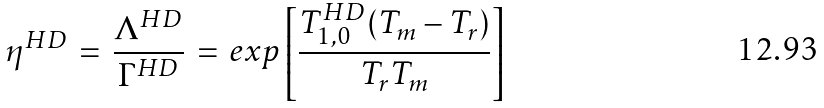<formula> <loc_0><loc_0><loc_500><loc_500>\eta ^ { H D } \, = \, \frac { \Lambda ^ { H D } } { \Gamma ^ { H D } } \, = \, e x p \left [ \frac { T _ { 1 , 0 } ^ { H D } ( T _ { m } - T _ { r } ) } { T _ { r } T _ { m } } \right ]</formula> 